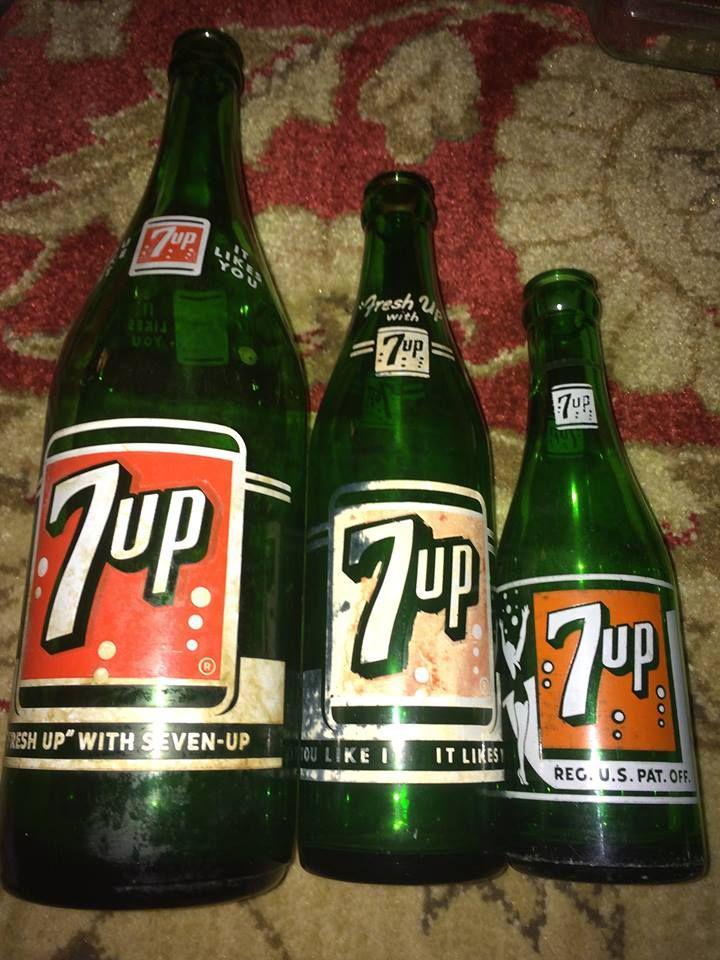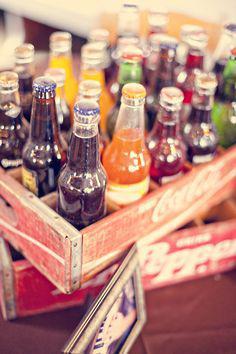The first image is the image on the left, the second image is the image on the right. Evaluate the accuracy of this statement regarding the images: "Dozens of bottles sit on a wall shelf in one of the images.". Is it true? Answer yes or no. No. The first image is the image on the left, the second image is the image on the right. Given the left and right images, does the statement "There is a wall of at least four shelves full of glass bottles." hold true? Answer yes or no. No. 